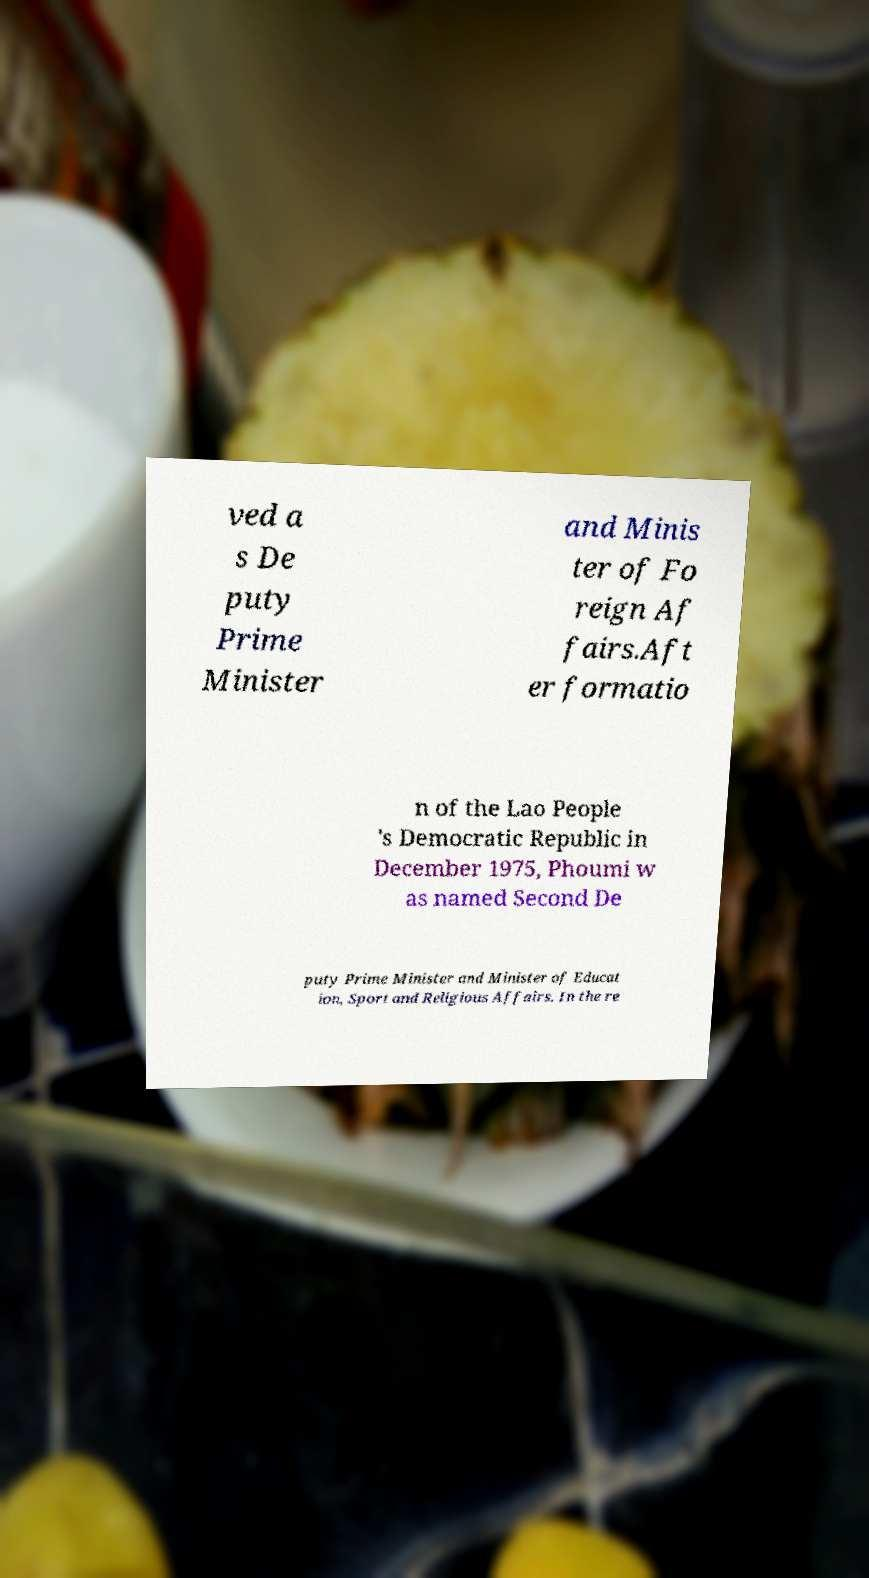Could you assist in decoding the text presented in this image and type it out clearly? ved a s De puty Prime Minister and Minis ter of Fo reign Af fairs.Aft er formatio n of the Lao People 's Democratic Republic in December 1975, Phoumi w as named Second De puty Prime Minister and Minister of Educat ion, Sport and Religious Affairs. In the re 